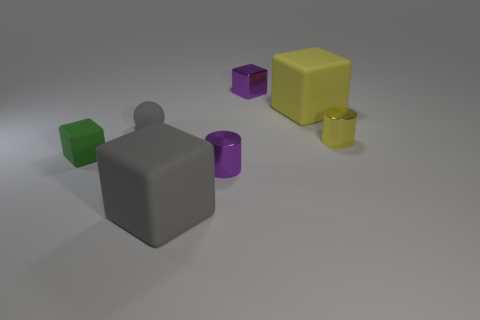Subtract all yellow blocks. How many blocks are left? 3 Add 2 big shiny blocks. How many objects exist? 9 Subtract all yellow cylinders. How many cylinders are left? 1 Subtract 1 cubes. How many cubes are left? 3 Add 2 yellow objects. How many yellow objects exist? 4 Subtract 1 yellow blocks. How many objects are left? 6 Subtract all cubes. How many objects are left? 3 Subtract all purple balls. Subtract all green blocks. How many balls are left? 1 Subtract all tiny purple matte objects. Subtract all small cylinders. How many objects are left? 5 Add 3 small purple metal cylinders. How many small purple metal cylinders are left? 4 